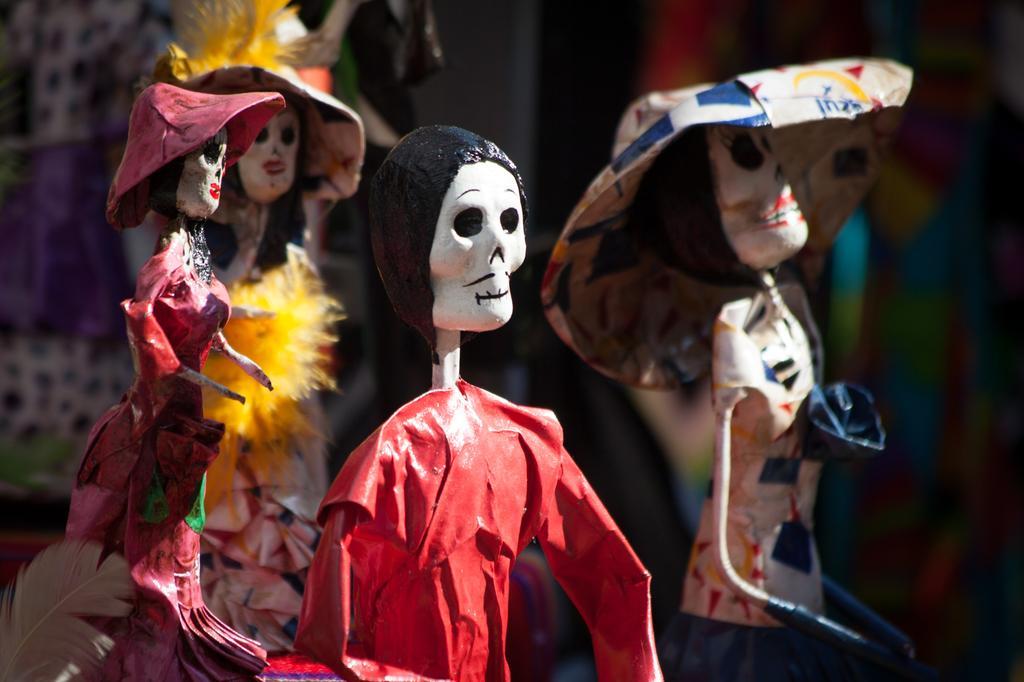Describe this image in one or two sentences. In this picture there are toys which are made up of clay. In the center, there is a toy in red in color. Behind it, there are toys with hats. 